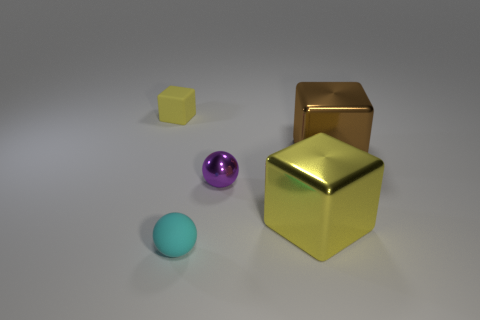Add 4 tiny brown rubber blocks. How many objects exist? 9 Subtract all cubes. How many objects are left? 2 Add 4 small cyan matte things. How many small cyan matte things are left? 5 Add 3 blocks. How many blocks exist? 6 Subtract 1 brown cubes. How many objects are left? 4 Subtract all cyan rubber balls. Subtract all large yellow shiny things. How many objects are left? 3 